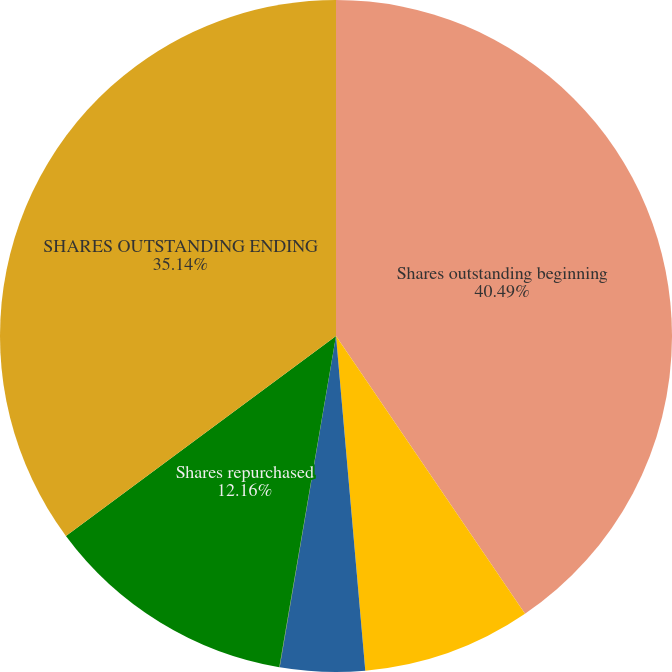Convert chart. <chart><loc_0><loc_0><loc_500><loc_500><pie_chart><fcel>Shares outstanding beginning<fcel>Vested restricted stock and<fcel>Issuance related to ESPP<fcel>Issuance related to SARS<fcel>Shares repurchased<fcel>SHARES OUTSTANDING ENDING<nl><fcel>40.49%<fcel>8.12%<fcel>4.07%<fcel>0.02%<fcel>12.16%<fcel>35.14%<nl></chart> 